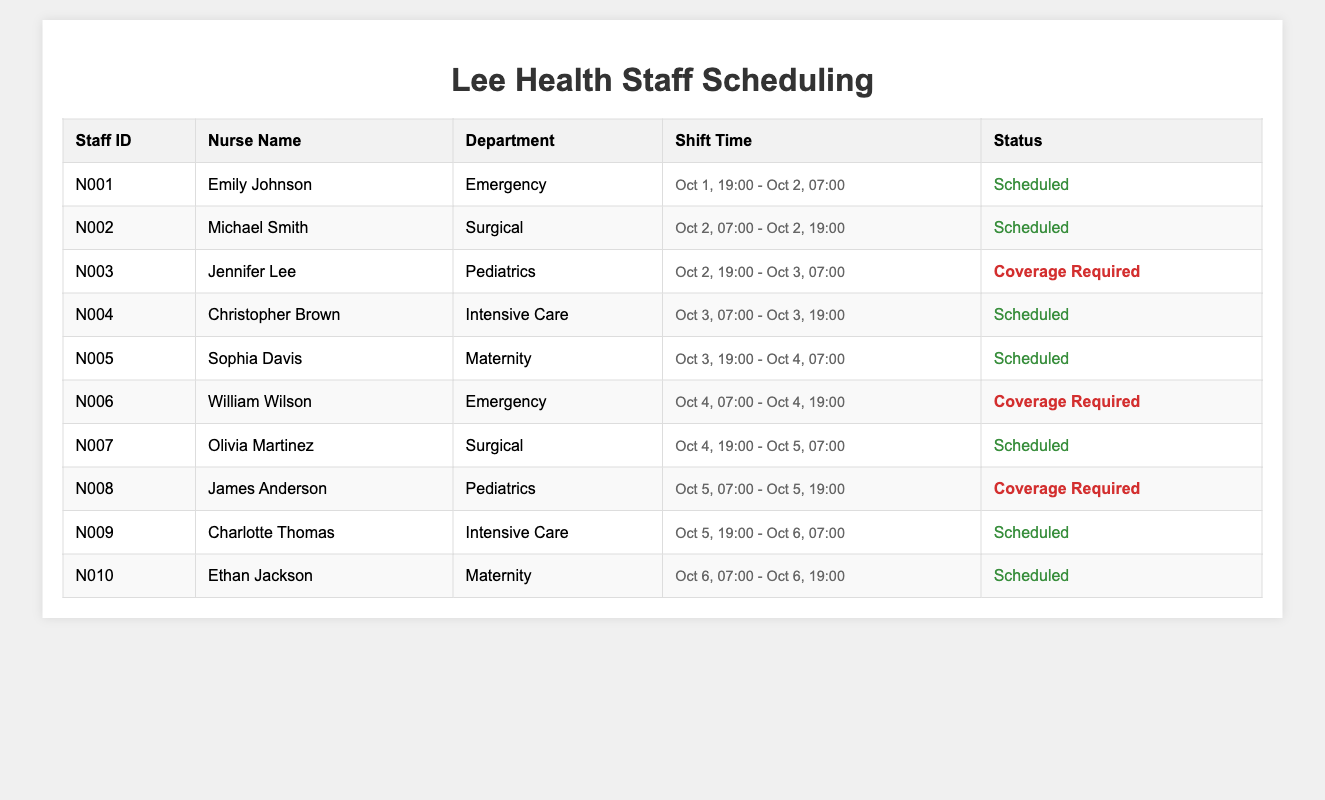What is the name of the nurse scheduled for the Emergency department on October 1st? Referring to the table, Emily Johnson is listed under the Emergency department with a scheduled shift from October 1st, 19:00 to October 2nd, 07:00.
Answer: Emily Johnson How many nurses are scheduled on October 3rd? On October 3rd, there are two scheduled nurses: Christopher Brown in Intensive Care and Sophia Davis in Maternity.
Answer: 2 Which department has a coverage requirement on October 2nd? The table indicates that the Pediatrics department has a coverage required for the shift starting October 2nd at 19:00, as Jennifer Lee is listed as not scheduled but with coverage required.
Answer: Pediatrics Is there a nurse scheduled for the Surgical department on October 4th? Checking the table, Olivia Martinez is scheduled in the Surgical department on October 4th from 19:00 to 07:00 the next day.
Answer: Yes What is the total number of coverage required shifts across all departments? There are four entries marked as coverage required: Jennifer Lee (Pediatrics), William Wilson (Emergency), James Anderson (Pediatrics), and Christopher Brown (Intensive Care) on different dates. Therefore, the total is 4.
Answer: 4 What are the names of the nurses scheduled on October 4th? On October 4th, William Wilson in the Emergency department and Olivia Martinez in the Surgical department are scheduled.
Answer: William Wilson, Olivia Martinez Which department has the most scheduled shifts based on the table? By counting the scheduled shifts for each department, the Maternity department has 2 shifts (Sophia Davis and Ethan Jackson) while the others have only 1, making it the department with the most scheduled shifts.
Answer: Maternity Is there a nurse scheduled for the Pediatrics department on October 5th? The table shows that, on October 5th, there is a coverage required listed for James Anderson in the Pediatrics department, which means no scheduled nurse is present during that shift.
Answer: No Which nurse has the earliest shift starting among all listed in the table? By examining all shifts, Emily Johnson has the earliest starting shift at 19:00 on October 1st.
Answer: Emily Johnson What is the duration of the shift for Michael Smith? Michael Smith's shift begins on October 2nd at 07:00 and ends at 19:00 on the same day, making the duration 12 hours.
Answer: 12 hours 